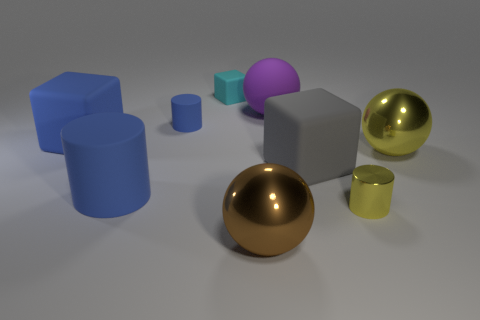Add 1 big matte objects. How many objects exist? 10 Subtract all blocks. How many objects are left? 6 Subtract all large purple matte cylinders. Subtract all big blue matte objects. How many objects are left? 7 Add 7 large blue blocks. How many large blue blocks are left? 8 Add 6 large brown objects. How many large brown objects exist? 7 Subtract 0 gray spheres. How many objects are left? 9 